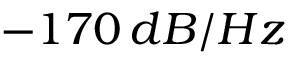Convert formula to latex. <formula><loc_0><loc_0><loc_500><loc_500>- 1 7 0 \, d B / H z</formula> 